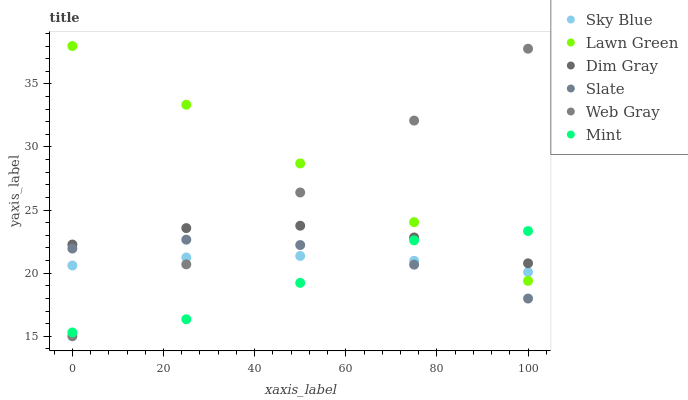Does Mint have the minimum area under the curve?
Answer yes or no. Yes. Does Lawn Green have the maximum area under the curve?
Answer yes or no. Yes. Does Dim Gray have the minimum area under the curve?
Answer yes or no. No. Does Dim Gray have the maximum area under the curve?
Answer yes or no. No. Is Lawn Green the smoothest?
Answer yes or no. Yes. Is Mint the roughest?
Answer yes or no. Yes. Is Dim Gray the smoothest?
Answer yes or no. No. Is Dim Gray the roughest?
Answer yes or no. No. Does Web Gray have the lowest value?
Answer yes or no. Yes. Does Slate have the lowest value?
Answer yes or no. No. Does Lawn Green have the highest value?
Answer yes or no. Yes. Does Dim Gray have the highest value?
Answer yes or no. No. Is Slate less than Dim Gray?
Answer yes or no. Yes. Is Dim Gray greater than Sky Blue?
Answer yes or no. Yes. Does Mint intersect Sky Blue?
Answer yes or no. Yes. Is Mint less than Sky Blue?
Answer yes or no. No. Is Mint greater than Sky Blue?
Answer yes or no. No. Does Slate intersect Dim Gray?
Answer yes or no. No. 